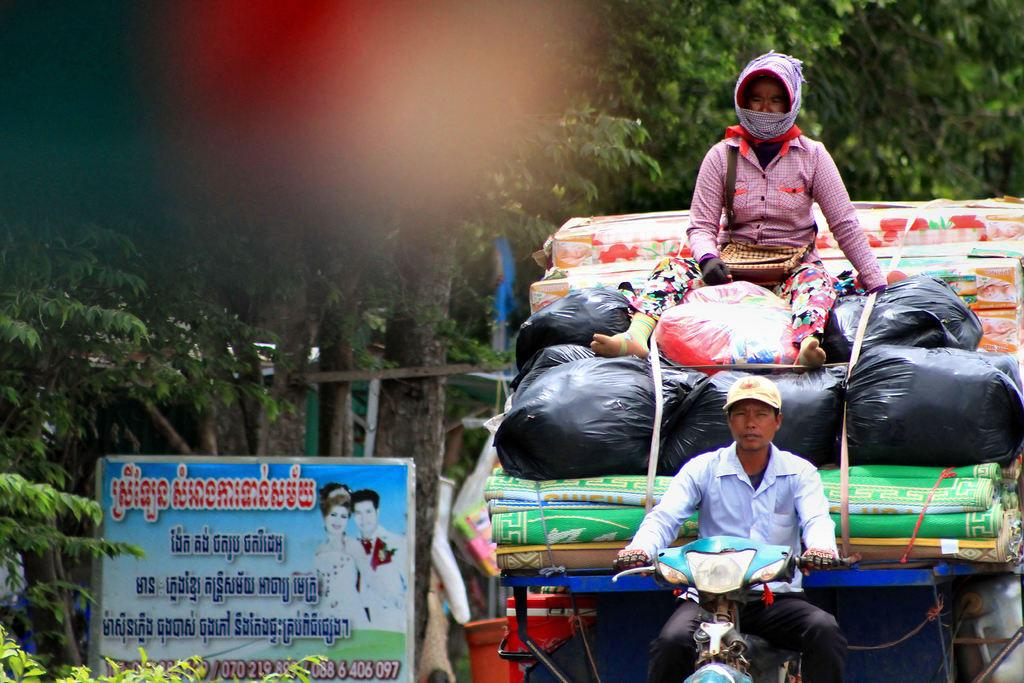What type of motor vehicle is in the image? There is a motor vehicle in the image, but the specific type is not mentioned. What is the motor vehicle carrying? The motor vehicle is carrying luggage. Can you describe the person in the image? There is a person sitting on top of the motor vehicle. What can be seen in the background of the image? There are trees and an information board in the background of the image. What type of snail can be seen crawling on the motor vehicle in the image? There is no snail present in the image; it only features a motor vehicle, luggage, and a person sitting on top. 